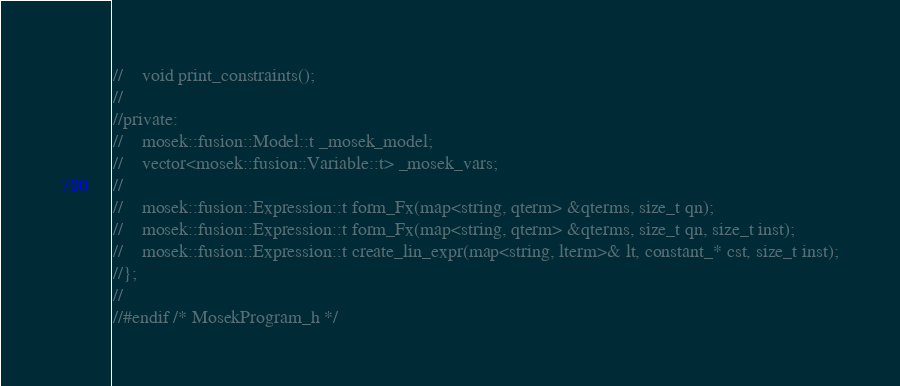Convert code to text. <code><loc_0><loc_0><loc_500><loc_500><_C_>//    void print_constraints();
//    
//private:
//    mosek::fusion::Model::t _mosek_model;
//    vector<mosek::fusion::Variable::t> _mosek_vars;
//
//    mosek::fusion::Expression::t form_Fx(map<string, qterm> &qterms, size_t qn);
//    mosek::fusion::Expression::t form_Fx(map<string, qterm> &qterms, size_t qn, size_t inst);
//    mosek::fusion::Expression::t create_lin_expr(map<string, lterm>& lt, constant_* cst, size_t inst);
//};
//
//#endif /* MosekProgram_h */
</code> 